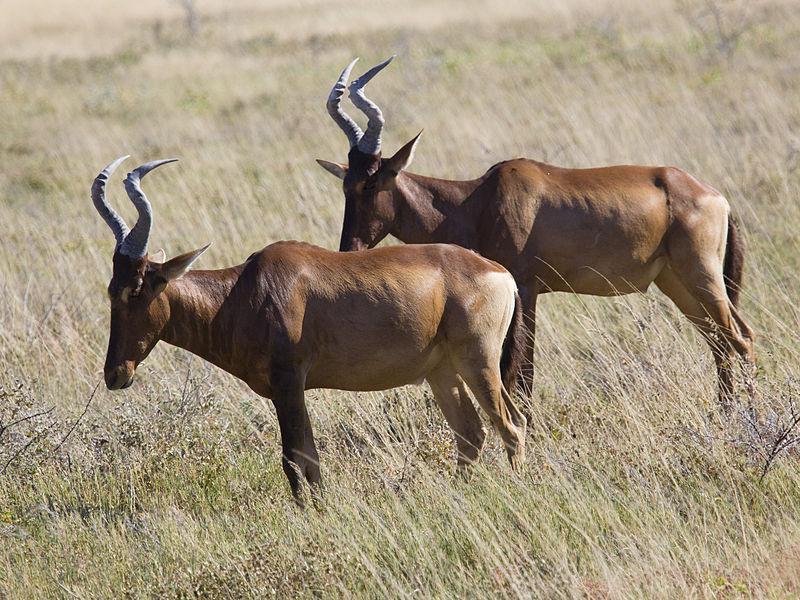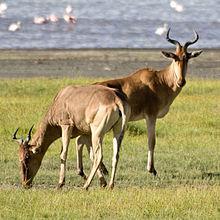The first image is the image on the left, the second image is the image on the right. For the images displayed, is the sentence "There are three gazelle-type creatures standing." factually correct? Answer yes or no. No. 